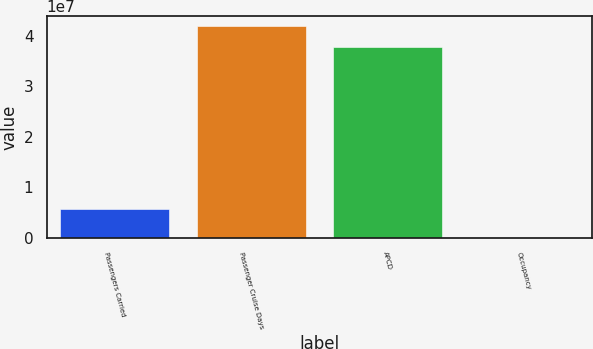Convert chart to OTSL. <chart><loc_0><loc_0><loc_500><loc_500><bar_chart><fcel>Passengers Carried<fcel>Passenger Cruise Days<fcel>APCD<fcel>Occupancy<nl><fcel>5.75475e+06<fcel>4.18697e+07<fcel>3.78446e+07<fcel>106.4<nl></chart> 